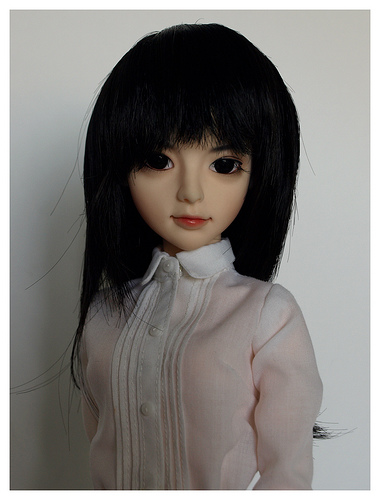<image>
Is the button in the tresses? No. The button is not contained within the tresses. These objects have a different spatial relationship. 